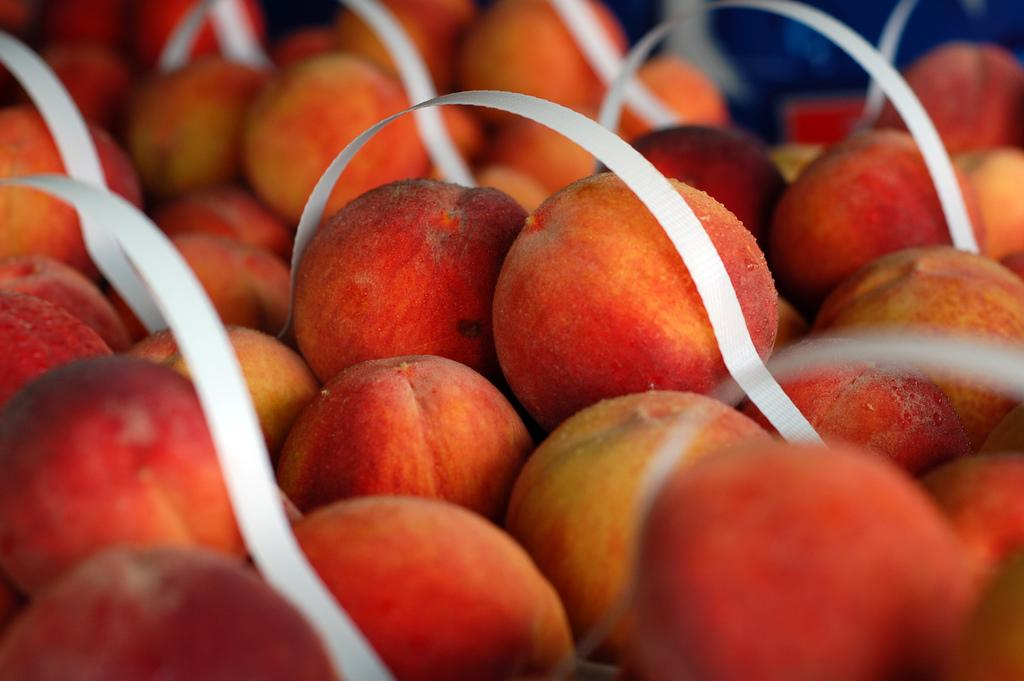What type of food items can be seen in the image? A: There are many fruits placed in one location in the image. Can you describe the arrangement of the fruits in the image? Unfortunately, the facts provided do not give enough information to describe the arrangement of the fruits. What might be the purpose of placing so many fruits together in one location? It is unclear from the facts provided what the purpose of placing the fruits together might be. How many yaks are visible in the image? There are no yaks present in the image; it features many fruits placed in one location. 